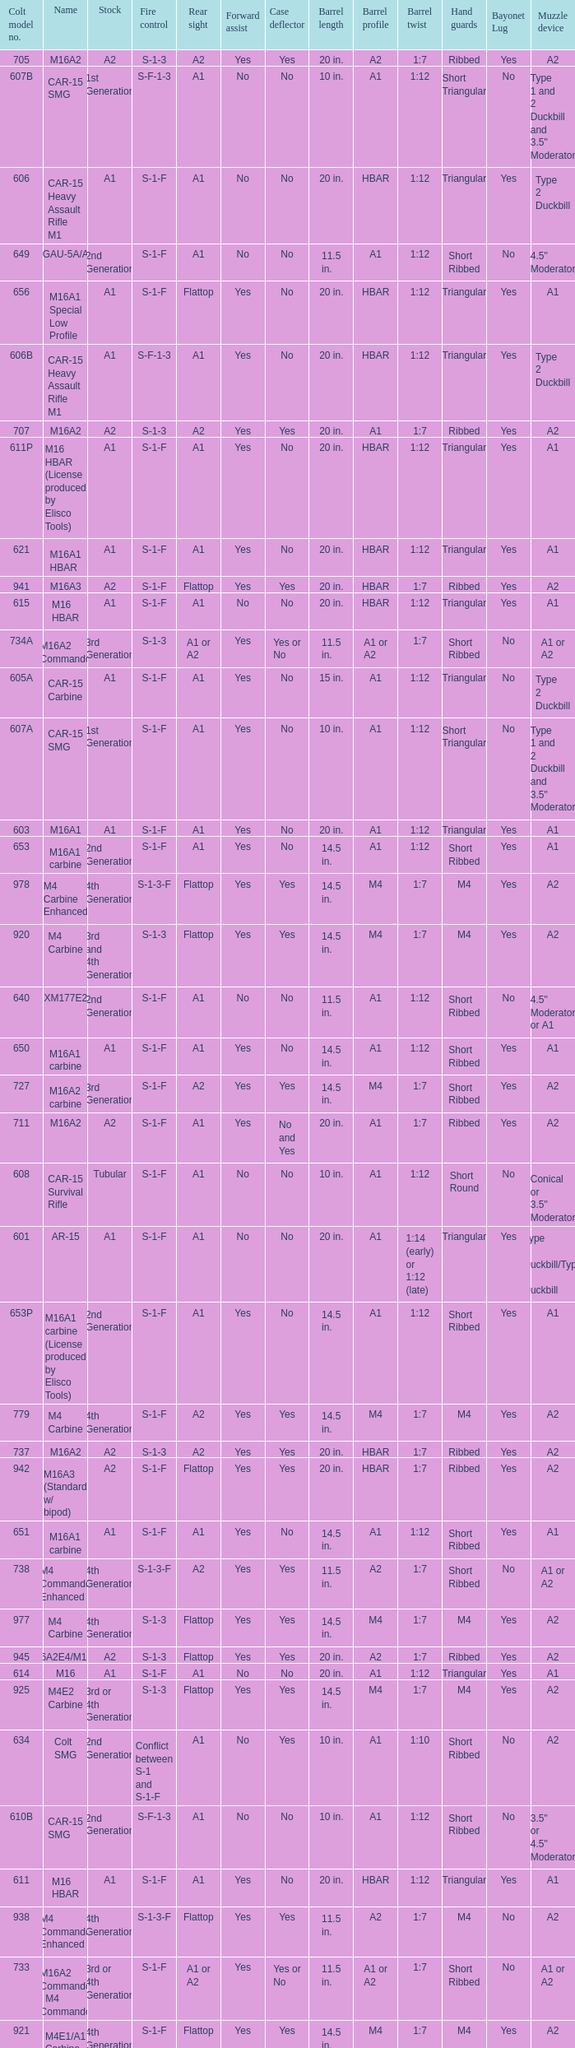What is the rear sight in the Cole model no. 735? A1 or A2. 